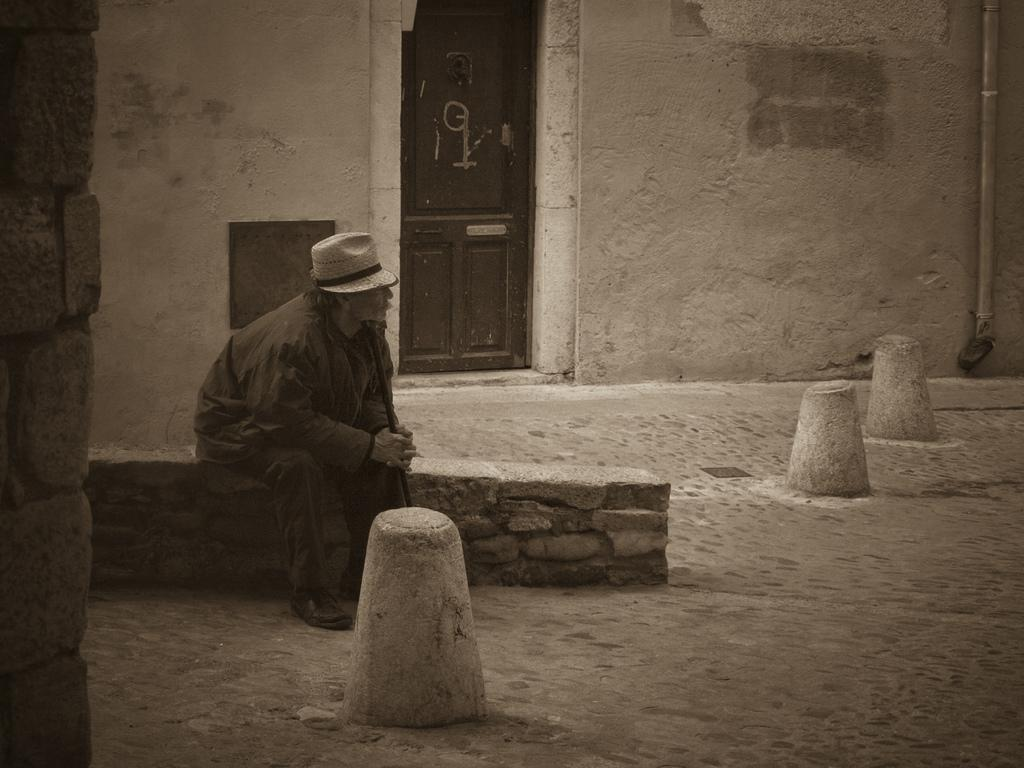What is the man in the image doing? The man is seated in the image. Can you describe the man's attire? The man is wearing a cap. What can be seen in the background of the image? There is a door and a pipe on the wall in the background of the image. What type of office equipment can be seen on the man's desk in the image? There is no desk or office equipment present in the image. 